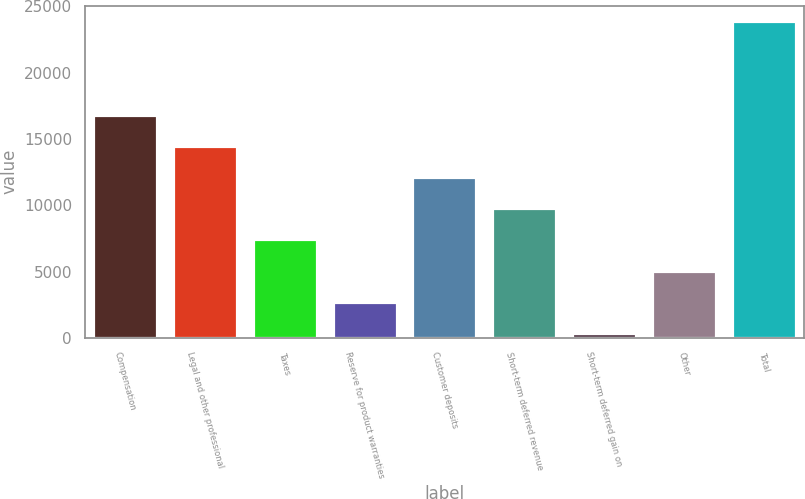<chart> <loc_0><loc_0><loc_500><loc_500><bar_chart><fcel>Compensation<fcel>Legal and other professional<fcel>Taxes<fcel>Reserve for product warranties<fcel>Customer deposits<fcel>Short-term deferred revenue<fcel>Short-term deferred gain on<fcel>Other<fcel>Total<nl><fcel>16814.5<fcel>14466<fcel>7420.5<fcel>2723.5<fcel>12117.5<fcel>9769<fcel>375<fcel>5072<fcel>23860<nl></chart> 